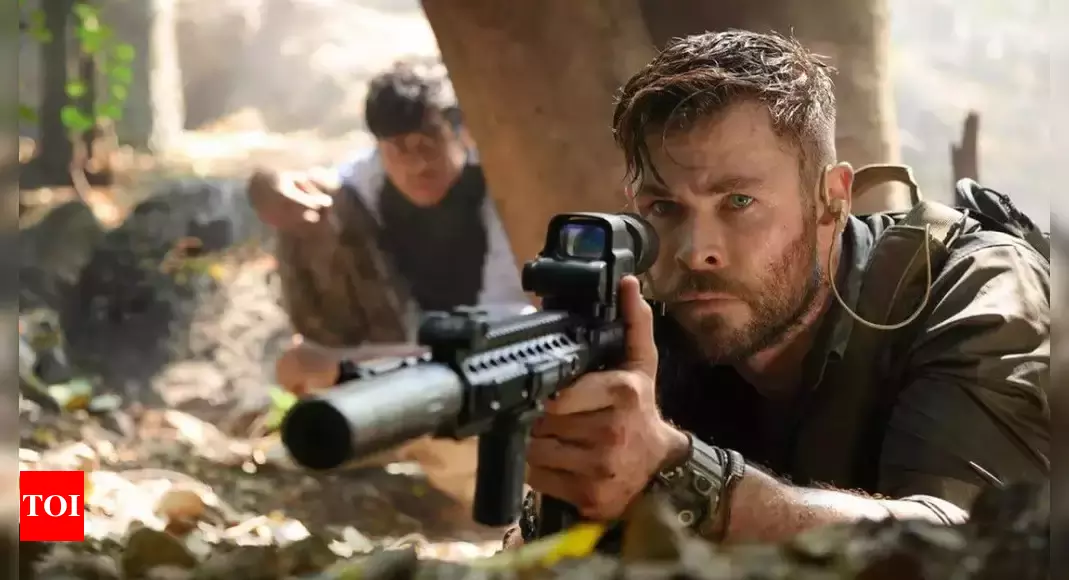If this scene were a turning point in the movie, what could be the possible outcomes following this encounter? If this scene is a turning point in the movie, possible outcomes could range from a covert attack that shifts the balance of power to a dramatic escape that leads to a chase. Tyler Rake's character might successfully neutralize a key adversary or obtain critical information that furthers their mission. Conversely, unforeseen complications could arise, such as reinforcements arriving, forcing the characters into a more perilous situation. This encounter could also serve as a moment of revelation, where hidden motives or alliances are exposed, fundamentally altering the character dynamics and the trajectory of the story. 